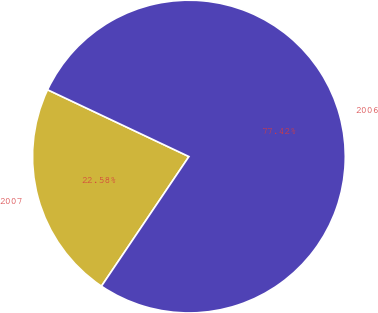<chart> <loc_0><loc_0><loc_500><loc_500><pie_chart><fcel>2007<fcel>2006<nl><fcel>22.58%<fcel>77.42%<nl></chart> 